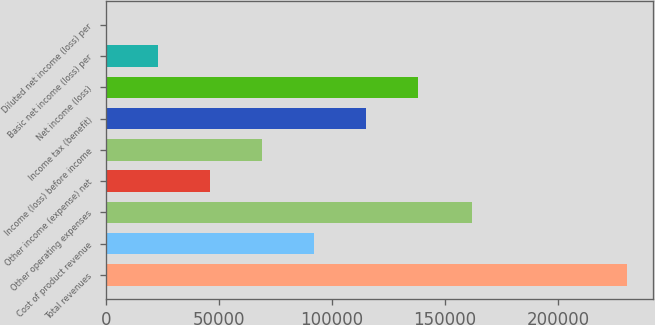Convert chart. <chart><loc_0><loc_0><loc_500><loc_500><bar_chart><fcel>Total revenues<fcel>Cost of product revenue<fcel>Other operating expenses<fcel>Other income (expense) net<fcel>Income (loss) before income<fcel>Income tax (benefit)<fcel>Net income (loss)<fcel>Basic net income (loss) per<fcel>Diluted net income (loss) per<nl><fcel>230311<fcel>92126<fcel>161700<fcel>46064.3<fcel>69095.2<fcel>115157<fcel>138188<fcel>23033.5<fcel>2.65<nl></chart> 